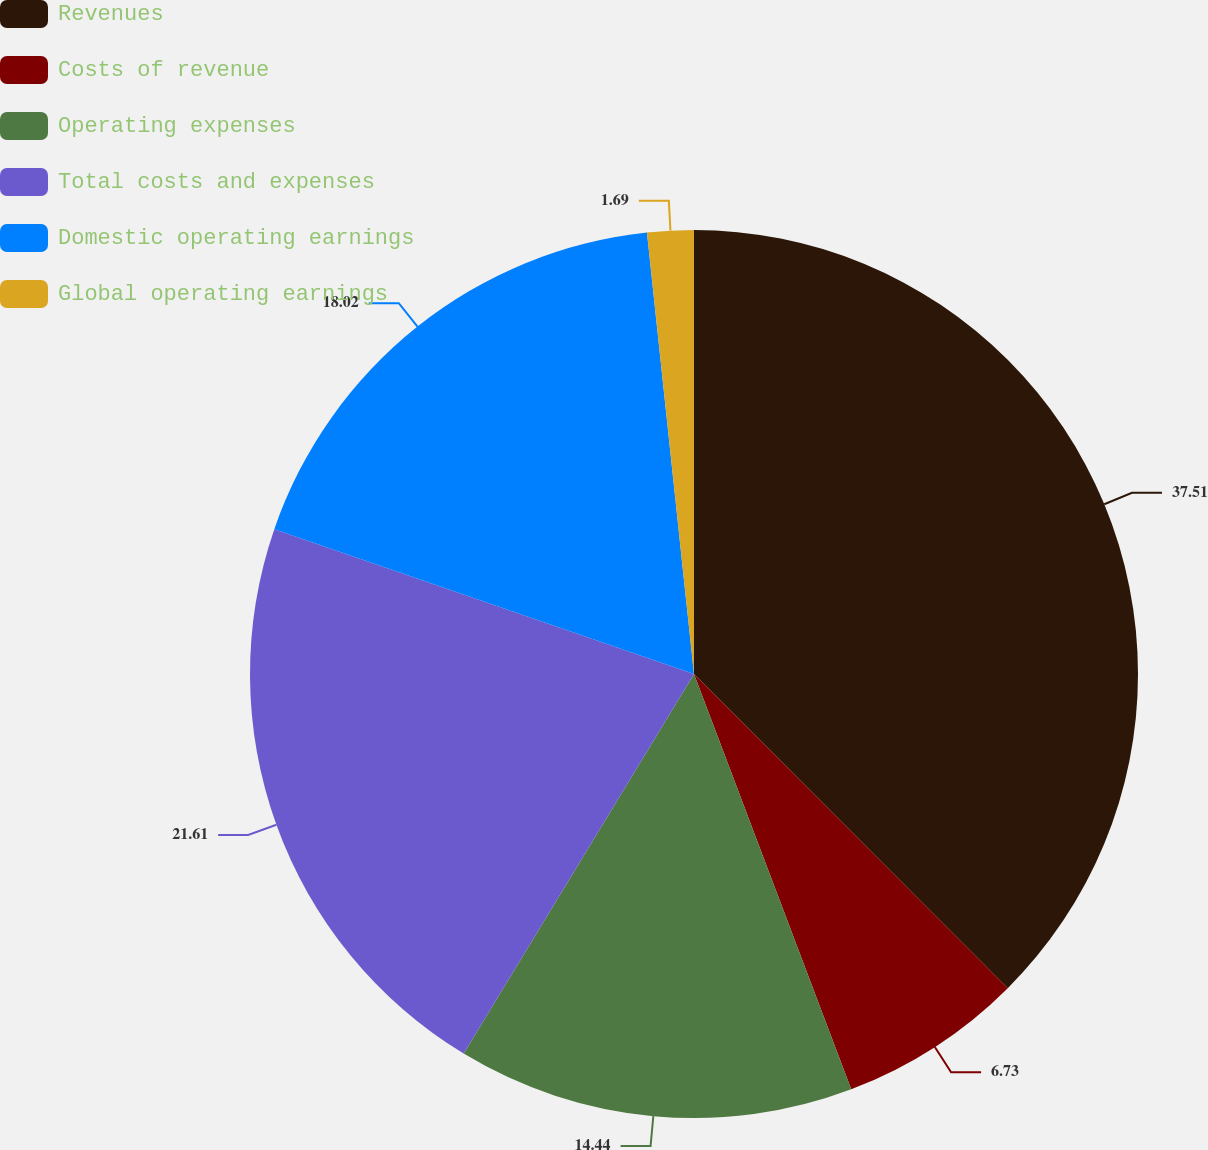Convert chart. <chart><loc_0><loc_0><loc_500><loc_500><pie_chart><fcel>Revenues<fcel>Costs of revenue<fcel>Operating expenses<fcel>Total costs and expenses<fcel>Domestic operating earnings<fcel>Global operating earnings<nl><fcel>37.51%<fcel>6.73%<fcel>14.44%<fcel>21.61%<fcel>18.02%<fcel>1.69%<nl></chart> 